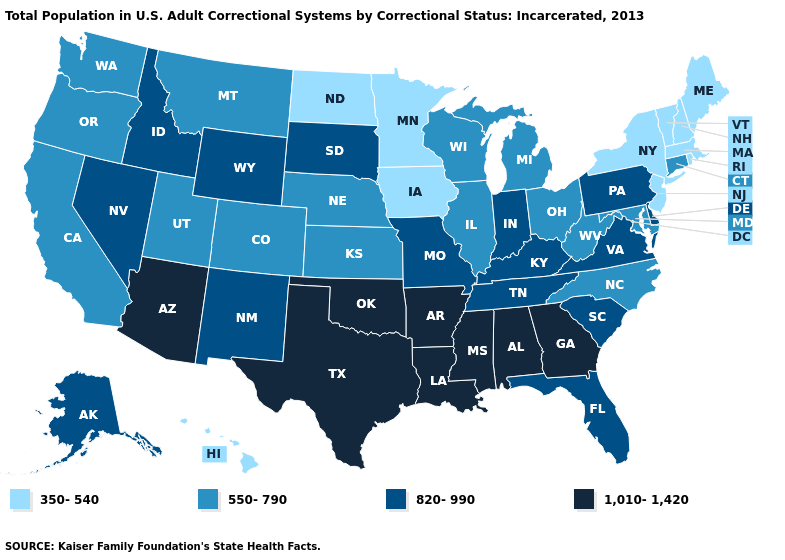What is the lowest value in the South?
Be succinct. 550-790. Name the states that have a value in the range 1,010-1,420?
Concise answer only. Alabama, Arizona, Arkansas, Georgia, Louisiana, Mississippi, Oklahoma, Texas. Name the states that have a value in the range 820-990?
Write a very short answer. Alaska, Delaware, Florida, Idaho, Indiana, Kentucky, Missouri, Nevada, New Mexico, Pennsylvania, South Carolina, South Dakota, Tennessee, Virginia, Wyoming. What is the highest value in the USA?
Short answer required. 1,010-1,420. What is the highest value in the USA?
Be succinct. 1,010-1,420. Name the states that have a value in the range 1,010-1,420?
Quick response, please. Alabama, Arizona, Arkansas, Georgia, Louisiana, Mississippi, Oklahoma, Texas. Name the states that have a value in the range 1,010-1,420?
Short answer required. Alabama, Arizona, Arkansas, Georgia, Louisiana, Mississippi, Oklahoma, Texas. Name the states that have a value in the range 820-990?
Give a very brief answer. Alaska, Delaware, Florida, Idaho, Indiana, Kentucky, Missouri, Nevada, New Mexico, Pennsylvania, South Carolina, South Dakota, Tennessee, Virginia, Wyoming. What is the value of North Carolina?
Concise answer only. 550-790. Name the states that have a value in the range 820-990?
Be succinct. Alaska, Delaware, Florida, Idaho, Indiana, Kentucky, Missouri, Nevada, New Mexico, Pennsylvania, South Carolina, South Dakota, Tennessee, Virginia, Wyoming. Name the states that have a value in the range 350-540?
Write a very short answer. Hawaii, Iowa, Maine, Massachusetts, Minnesota, New Hampshire, New Jersey, New York, North Dakota, Rhode Island, Vermont. Among the states that border Illinois , does Indiana have the highest value?
Quick response, please. Yes. Which states have the highest value in the USA?
Write a very short answer. Alabama, Arizona, Arkansas, Georgia, Louisiana, Mississippi, Oklahoma, Texas. What is the value of Arkansas?
Quick response, please. 1,010-1,420. How many symbols are there in the legend?
Answer briefly. 4. 